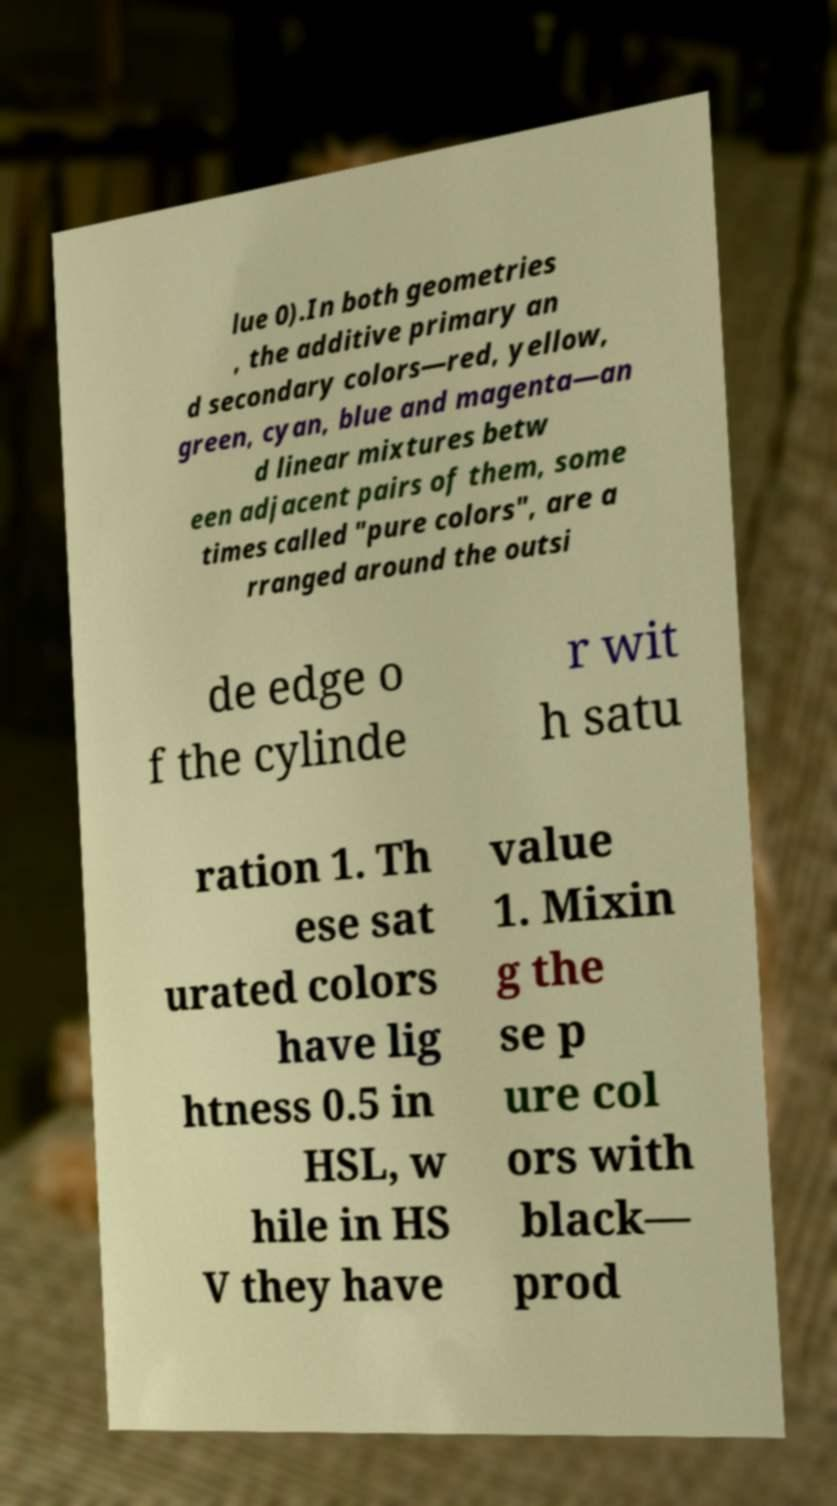Please read and relay the text visible in this image. What does it say? lue 0).In both geometries , the additive primary an d secondary colors—red, yellow, green, cyan, blue and magenta—an d linear mixtures betw een adjacent pairs of them, some times called "pure colors", are a rranged around the outsi de edge o f the cylinde r wit h satu ration 1. Th ese sat urated colors have lig htness 0.5 in HSL, w hile in HS V they have value 1. Mixin g the se p ure col ors with black— prod 